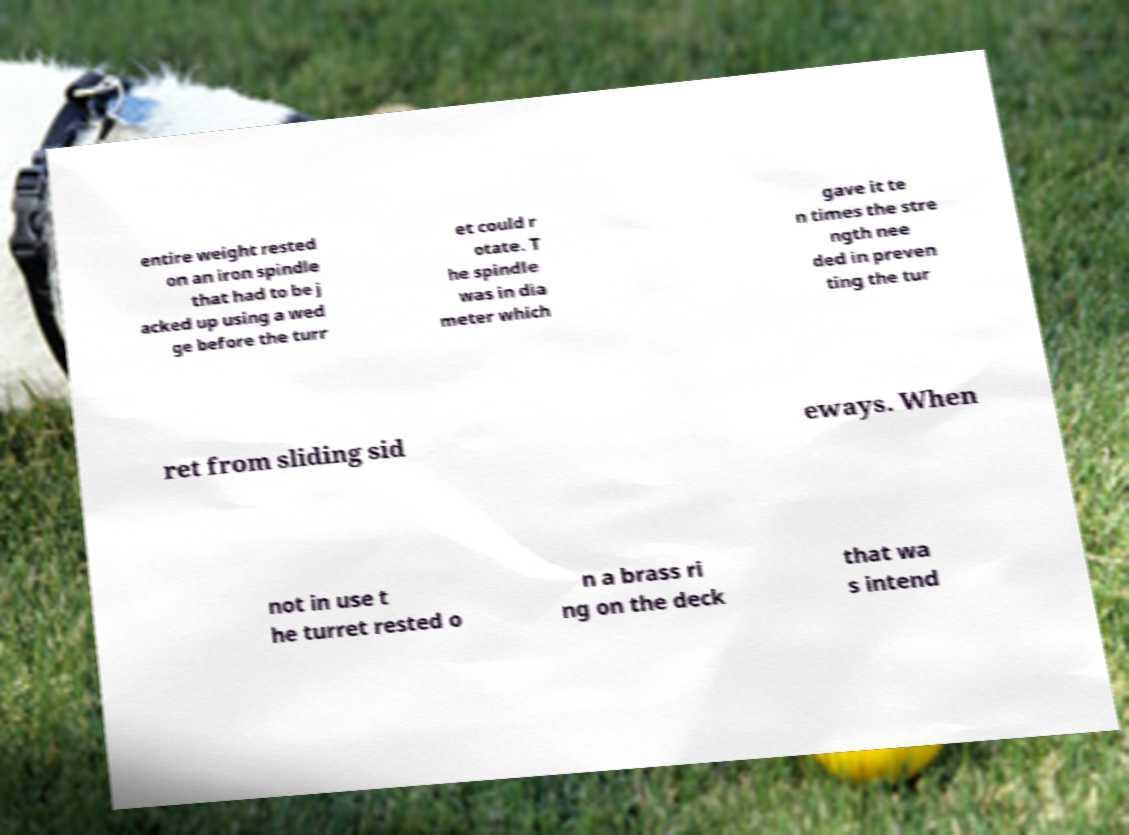I need the written content from this picture converted into text. Can you do that? entire weight rested on an iron spindle that had to be j acked up using a wed ge before the turr et could r otate. T he spindle was in dia meter which gave it te n times the stre ngth nee ded in preven ting the tur ret from sliding sid eways. When not in use t he turret rested o n a brass ri ng on the deck that wa s intend 